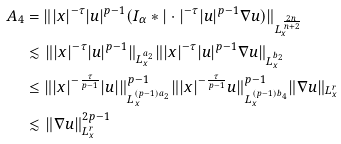<formula> <loc_0><loc_0><loc_500><loc_500>A _ { 4 } & = \| | x | ^ { - \tau } | u | ^ { p - 1 } ( I _ { \alpha } \ast | \cdot | ^ { - \tau } | u | ^ { p - 1 } \nabla u ) \| _ { L _ { x } ^ { \frac { 2 n } { n + 2 } } } \\ & \lesssim \| | x | ^ { - \tau } | u | ^ { p - 1 } \| _ { L _ { x } ^ { a _ { 2 } } } \| | x | ^ { - \tau } | u | ^ { p - 1 } \nabla u \| _ { L _ { x } ^ { b _ { 2 } } } \\ & \leq \| | x | ^ { - \frac { \tau } { p - 1 } } | u | \| ^ { p - 1 } _ { L _ { x } ^ { ( p - 1 ) a _ { 2 } } } \| | x | ^ { - \frac { \tau } { p - 1 } } u \| ^ { p - 1 } _ { L _ { x } ^ { ( p - 1 ) b _ { 4 } } } \| \nabla u \| _ { L _ { x } ^ { r } } \\ & \lesssim \| \nabla u \| _ { L _ { x } ^ { r } } ^ { 2 p - 1 }</formula> 